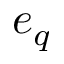<formula> <loc_0><loc_0><loc_500><loc_500>e _ { q }</formula> 